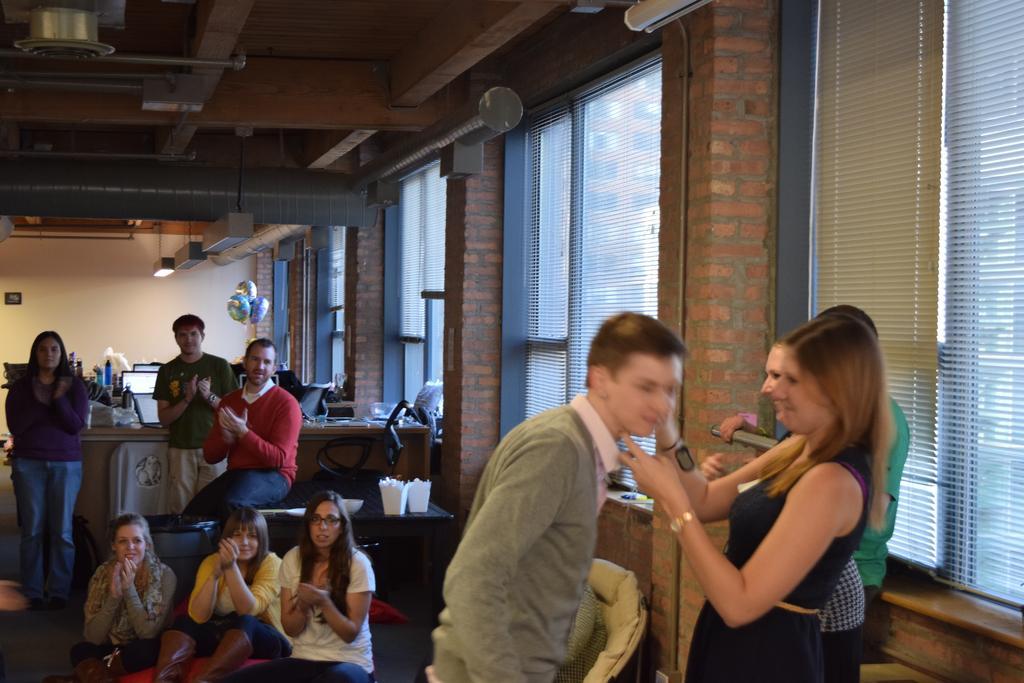Describe this image in one or two sentences. This picture describes about group of people, few are sitting and few are standing, in the background we can see window blinds, lights and balloons. 